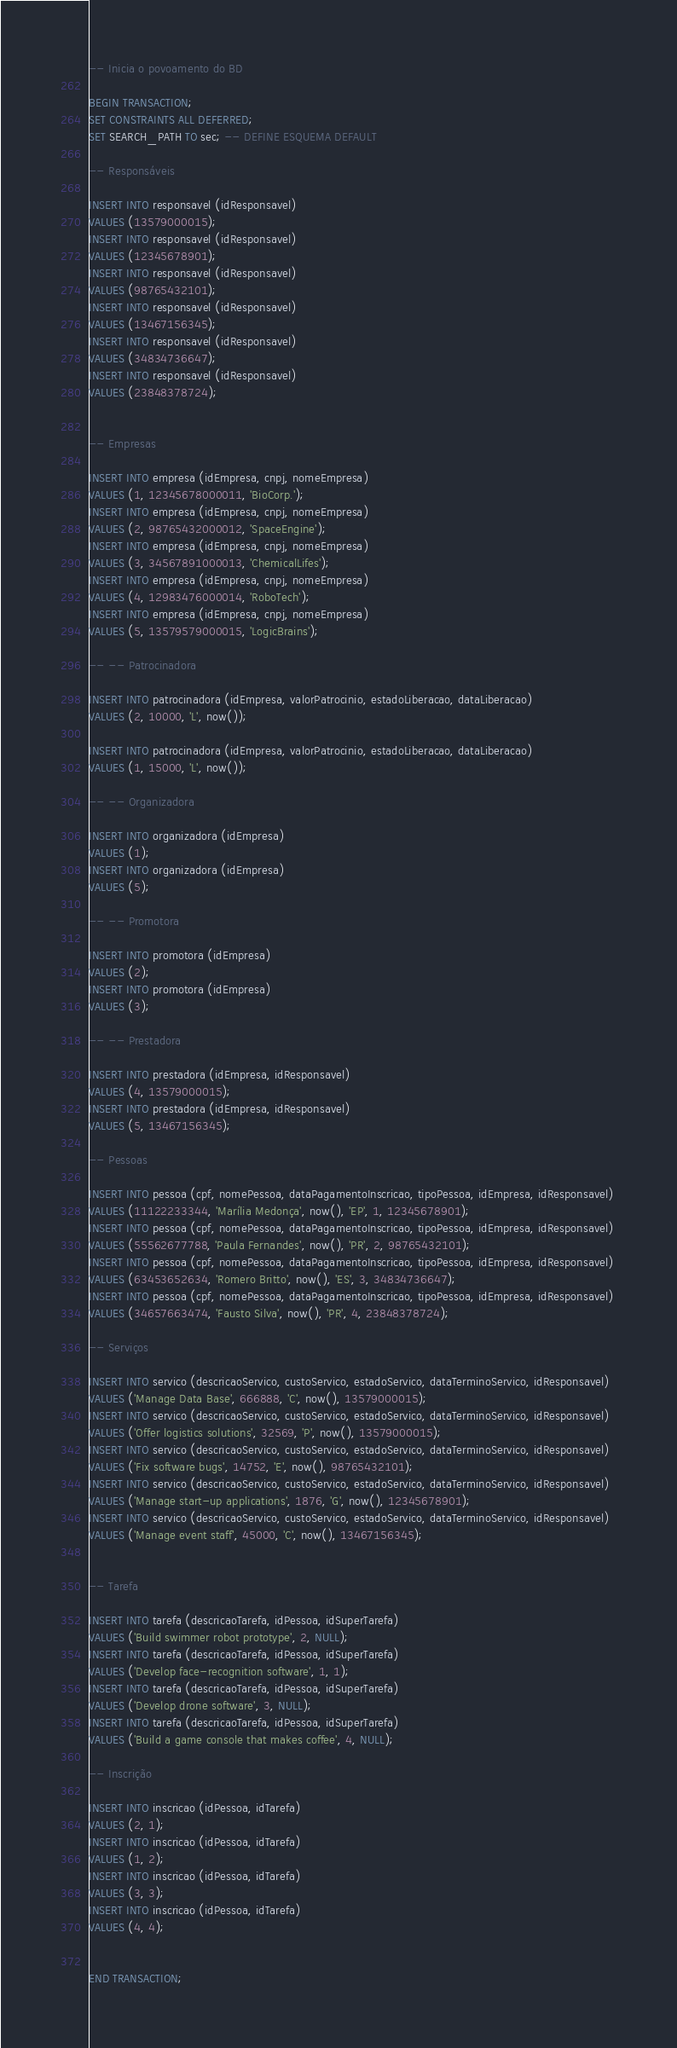<code> <loc_0><loc_0><loc_500><loc_500><_SQL_>-- Inicia o povoamento do BD

BEGIN TRANSACTION;
SET CONSTRAINTS ALL DEFERRED;
SET SEARCH_PATH TO sec; -- DEFINE ESQUEMA DEFAULT

-- Responsáveis

INSERT INTO responsavel (idResponsavel) 
VALUES (13579000015);
INSERT INTO responsavel (idResponsavel) 
VALUES (12345678901);
INSERT INTO responsavel (idResponsavel) 
VALUES (98765432101);
INSERT INTO responsavel (idResponsavel) 
VALUES (13467156345);
INSERT INTO responsavel (idResponsavel) 
VALUES (34834736647);
INSERT INTO responsavel (idResponsavel) 
VALUES (23848378724);


-- Empresas

INSERT INTO empresa (idEmpresa, cnpj, nomeEmpresa) 
VALUES (1, 12345678000011, 'BioCorp.');
INSERT INTO empresa (idEmpresa, cnpj, nomeEmpresa) 
VALUES (2, 98765432000012, 'SpaceEngine');
INSERT INTO empresa (idEmpresa, cnpj, nomeEmpresa) 
VALUES (3, 34567891000013, 'ChemicalLifes');
INSERT INTO empresa (idEmpresa, cnpj, nomeEmpresa) 
VALUES (4, 12983476000014, 'RoboTech');
INSERT INTO empresa (idEmpresa, cnpj, nomeEmpresa) 
VALUES (5, 13579579000015, 'LogicBrains');

-- -- Patrocinadora

INSERT INTO patrocinadora (idEmpresa, valorPatrocinio, estadoLiberacao, dataLiberacao) 
VALUES (2, 10000, 'L', now());

INSERT INTO patrocinadora (idEmpresa, valorPatrocinio, estadoLiberacao, dataLiberacao) 
VALUES (1, 15000, 'L', now());

-- -- Organizadora

INSERT INTO organizadora (idEmpresa) 
VALUES (1);
INSERT INTO organizadora (idEmpresa) 
VALUES (5);

-- -- Promotora

INSERT INTO promotora (idEmpresa) 
VALUES (2);
INSERT INTO promotora (idEmpresa) 
VALUES (3);

-- -- Prestadora

INSERT INTO prestadora (idEmpresa, idResponsavel) 
VALUES (4, 13579000015);
INSERT INTO prestadora (idEmpresa, idResponsavel) 
VALUES (5, 13467156345);

-- Pessoas

INSERT INTO pessoa (cpf, nomePessoa, dataPagamentoInscricao, tipoPessoa, idEmpresa, idResponsavel) 
VALUES (11122233344, 'Marília Medonça', now(), 'EP', 1, 12345678901);
INSERT INTO pessoa (cpf, nomePessoa, dataPagamentoInscricao, tipoPessoa, idEmpresa, idResponsavel) 
VALUES (55562677788, 'Paula Fernandes', now(), 'PR', 2, 98765432101);
INSERT INTO pessoa (cpf, nomePessoa, dataPagamentoInscricao, tipoPessoa, idEmpresa, idResponsavel) 
VALUES (63453652634, 'Romero Britto', now(), 'ES', 3, 34834736647);
INSERT INTO pessoa (cpf, nomePessoa, dataPagamentoInscricao, tipoPessoa, idEmpresa, idResponsavel) 
VALUES (34657663474, 'Fausto Silva', now(), 'PR', 4, 23848378724);

-- Serviços

INSERT INTO servico (descricaoServico, custoServico, estadoServico, dataTerminoServico, idResponsavel) 
VALUES ('Manage Data Base', 666888, 'C', now(), 13579000015);
INSERT INTO servico (descricaoServico, custoServico, estadoServico, dataTerminoServico, idResponsavel) 
VALUES ('Offer logistics solutions', 32569, 'P', now(), 13579000015);
INSERT INTO servico (descricaoServico, custoServico, estadoServico, dataTerminoServico, idResponsavel) 
VALUES ('Fix software bugs', 14752, 'E', now(), 98765432101);
INSERT INTO servico (descricaoServico, custoServico, estadoServico, dataTerminoServico, idResponsavel) 
VALUES ('Manage start-up applications', 1876, 'G', now(), 12345678901);
INSERT INTO servico (descricaoServico, custoServico, estadoServico, dataTerminoServico, idResponsavel) 
VALUES ('Manage event staff', 45000, 'C', now(), 13467156345);


-- Tarefa

INSERT INTO tarefa (descricaoTarefa, idPessoa, idSuperTarefa) 
VALUES ('Build swimmer robot prototype', 2, NULL);
INSERT INTO tarefa (descricaoTarefa, idPessoa, idSuperTarefa) 
VALUES ('Develop face-recognition software', 1, 1);
INSERT INTO tarefa (descricaoTarefa, idPessoa, idSuperTarefa) 
VALUES ('Develop drone software', 3, NULL);
INSERT INTO tarefa (descricaoTarefa, idPessoa, idSuperTarefa) 
VALUES ('Build a game console that makes coffee', 4, NULL);

-- Inscrição

INSERT INTO inscricao (idPessoa, idTarefa) 
VALUES (2, 1);
INSERT INTO inscricao (idPessoa, idTarefa) 
VALUES (1, 2);
INSERT INTO inscricao (idPessoa, idTarefa) 
VALUES (3, 3);
INSERT INTO inscricao (idPessoa, idTarefa) 
VALUES (4, 4);


END TRANSACTION;
</code> 